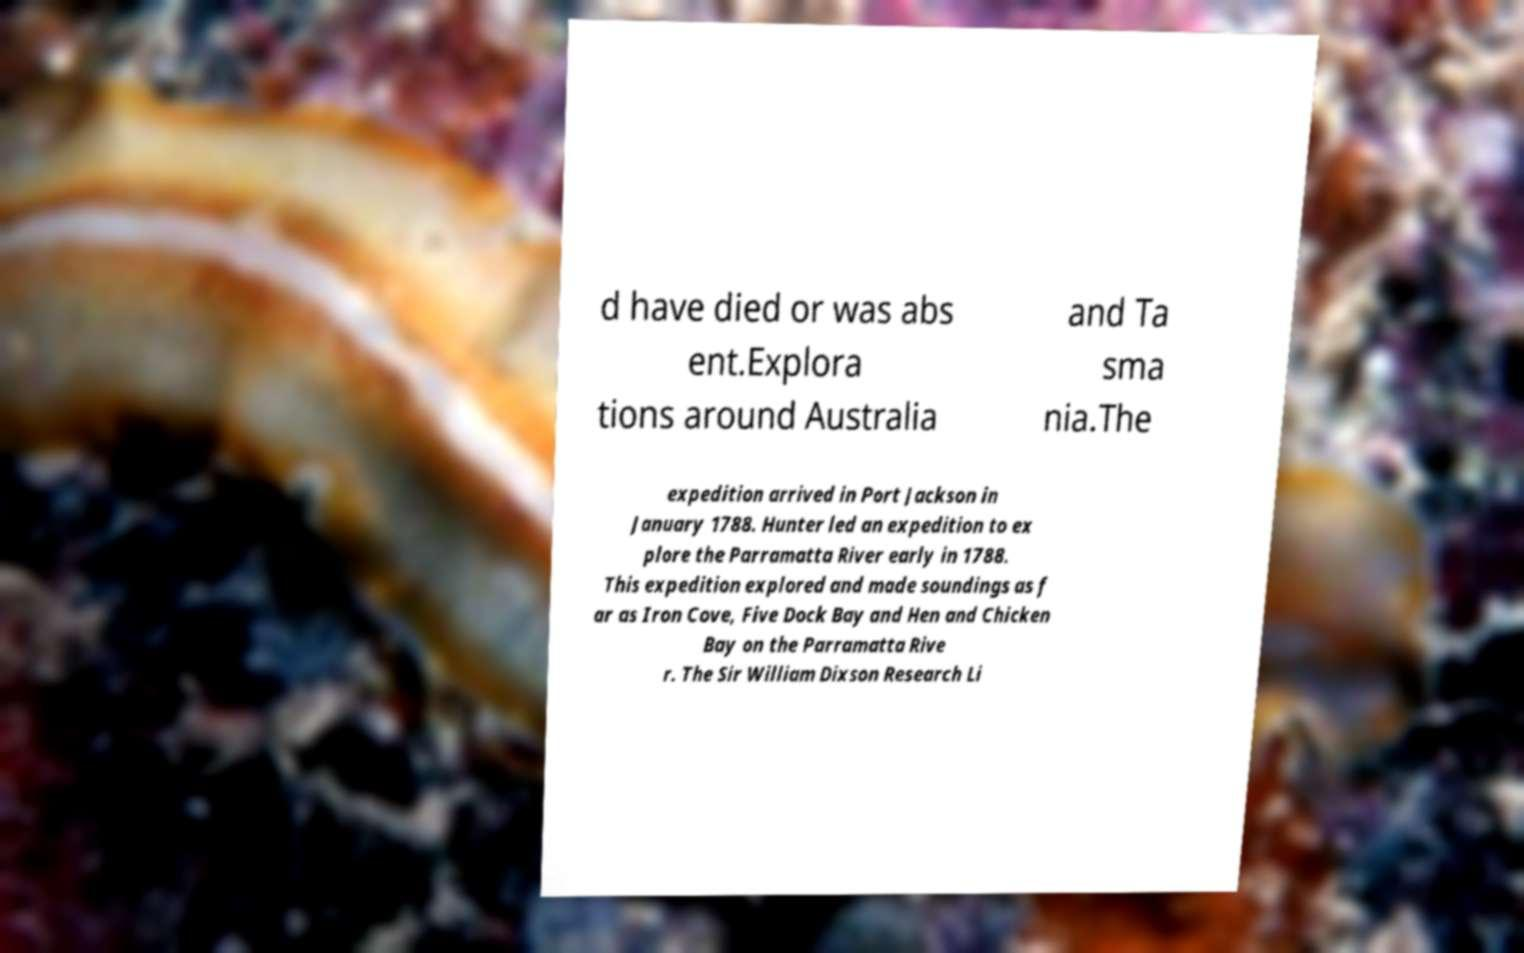Could you assist in decoding the text presented in this image and type it out clearly? d have died or was abs ent.Explora tions around Australia and Ta sma nia.The expedition arrived in Port Jackson in January 1788. Hunter led an expedition to ex plore the Parramatta River early in 1788. This expedition explored and made soundings as f ar as Iron Cove, Five Dock Bay and Hen and Chicken Bay on the Parramatta Rive r. The Sir William Dixson Research Li 